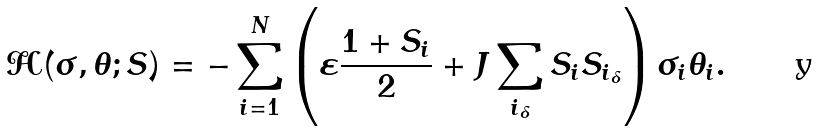Convert formula to latex. <formula><loc_0><loc_0><loc_500><loc_500>\mathcal { H } ( \sigma , \theta ; S ) = - \sum _ { i = 1 } ^ { N } \left ( \varepsilon \frac { 1 + S _ { i } } { 2 } + J \sum _ { i _ { \delta } } S _ { i } S _ { i _ { \delta } } \right ) \sigma _ { i } \theta _ { i } .</formula> 